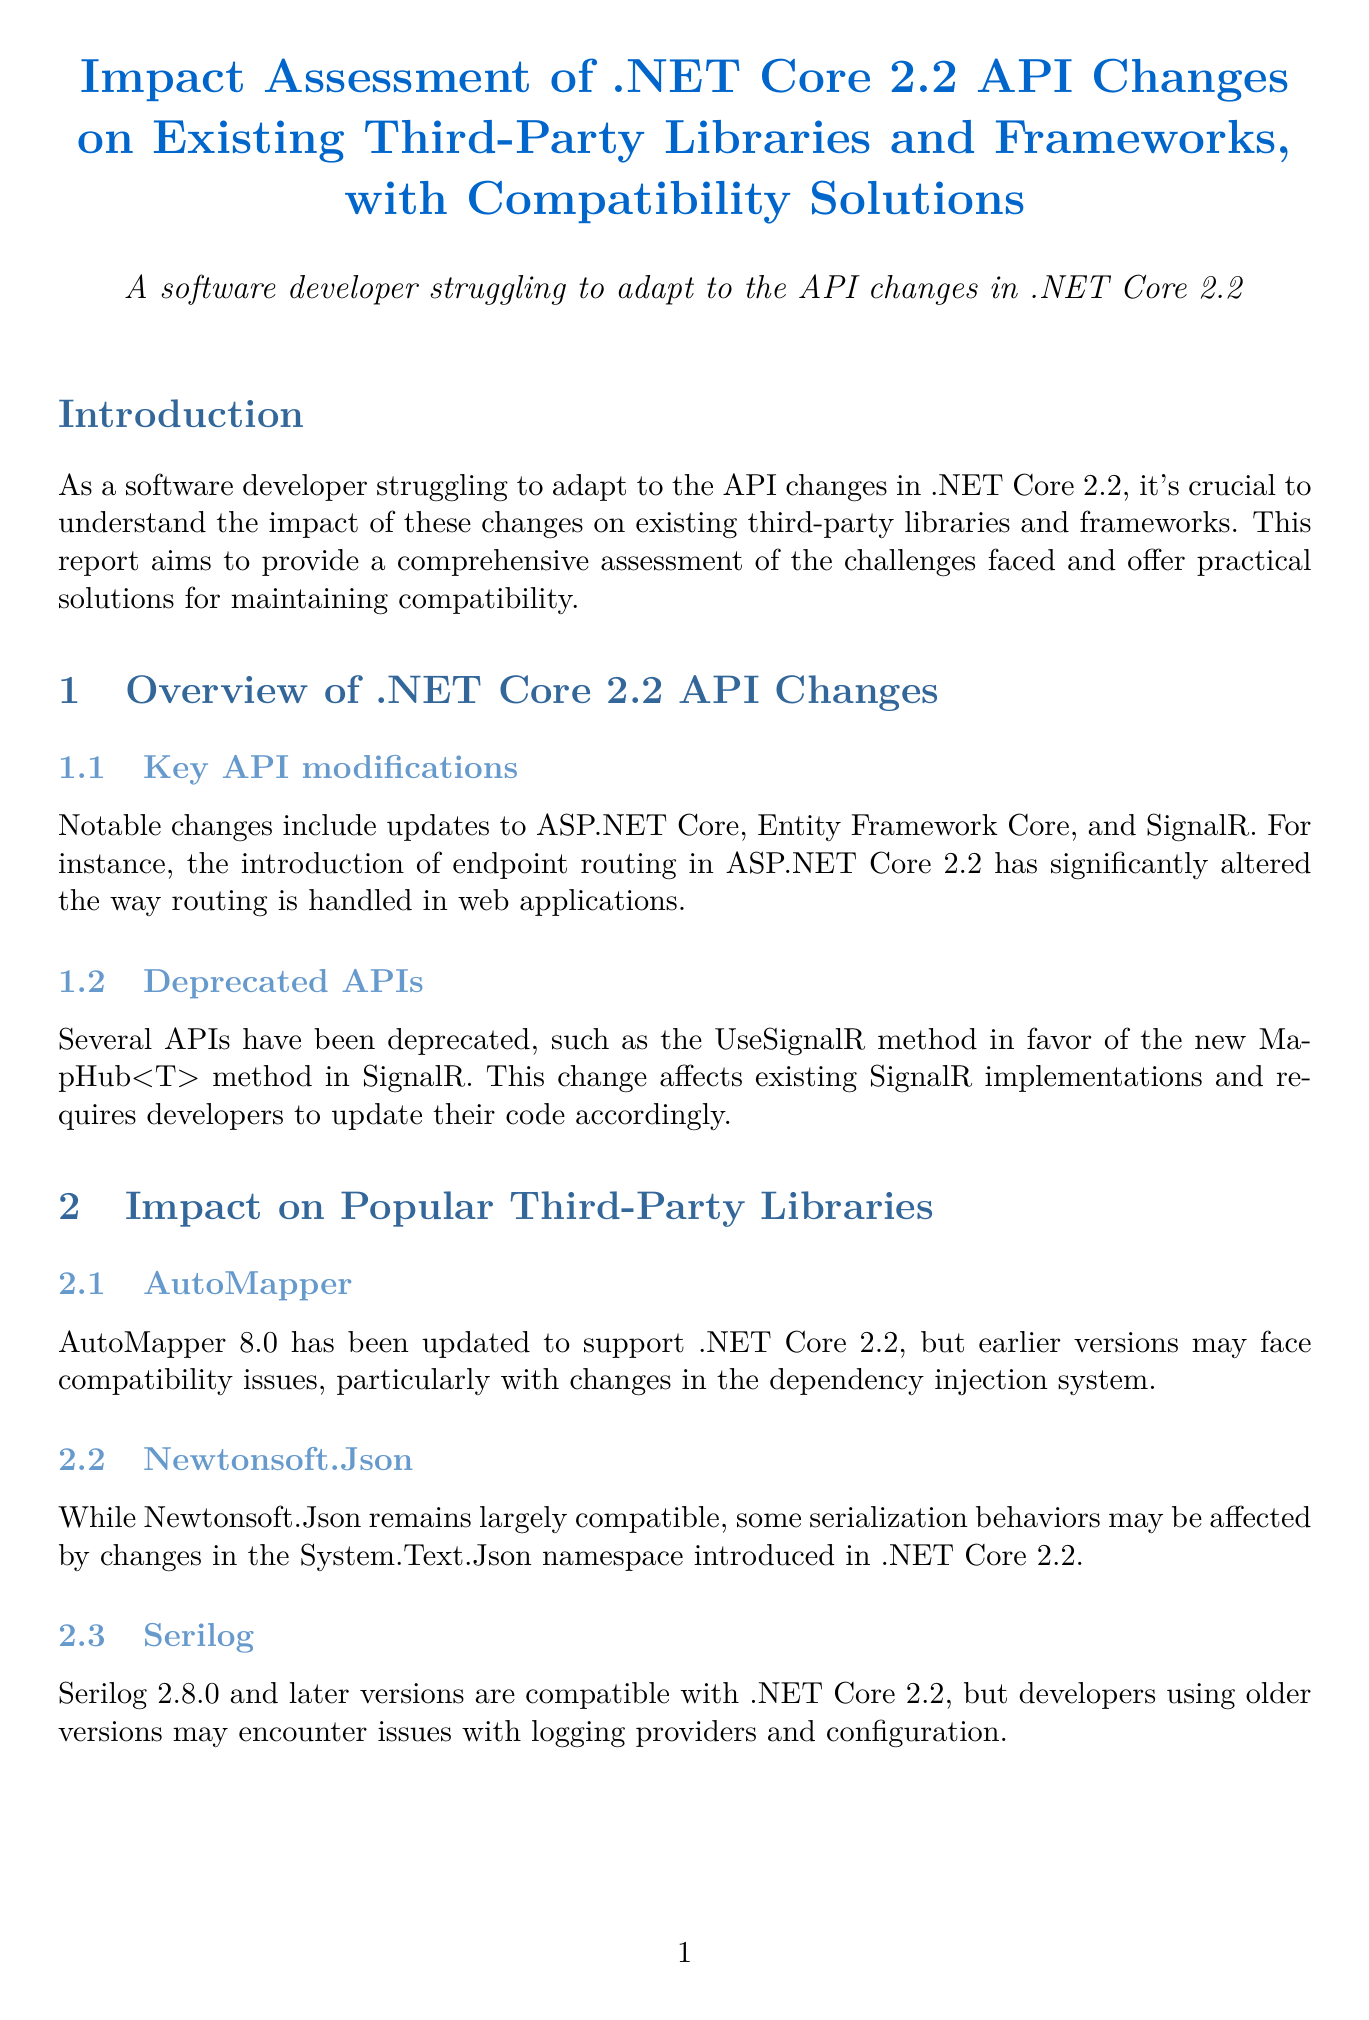What is the title of the report? The title of the report is prominently mentioned at the beginning, summarizing its focus on .NET Core 2.2 API changes and compatibility solutions.
Answer: Impact Assessment of .NET Core 2.2 API Changes on Existing Third-Party Libraries and Frameworks, with Compatibility Solutions Which third-party library is mentioned as needing updates for compatibility with .NET Core 2.2? The report discusses the need for AutoMapper, among others, to be updated to function correctly with .NET Core 2.2.
Answer: AutoMapper What method has been deprecated in SignalR? The report specifies that the UseSignalR method in SignalR is deprecated, indicating a significant API change that developers need to be aware of.
Answer: UseSignalR Which version of NHibernate supports .NET Core 2.2? The report outlines that NHibernate 5.2 and above are compatible with .NET Core 2.2, indicating the versions that developers should use.
Answer: 5.2 What is one of the compatibility solutions suggested in the report? The document suggests implementing compatibility shims as one of several solutions to maintain compatibility with older APIs while migrating to newer ones.
Answer: Implementing compatibility shims What tool can help identify compatibility issues in .NET versions? The report recommends Microsoft's API Port tool as a resource for identifying compatibility issues and suggesting fixes for various .NET versions.
Answer: API Port What is a primary challenge for developers migrating to .NET Core 2.2? The report states that outdated NuGet packages pose challenges when migrating legacy projects to .NET Core 2.2.
Answer: Outdated NuGet packages What is the compatibility version for Serilog mentioned in the report? The report indicates that Serilog version 2.8.0 and later versions are compatible with .NET Core 2.2, guiding users on which versions to use.
Answer: 2.8.0 